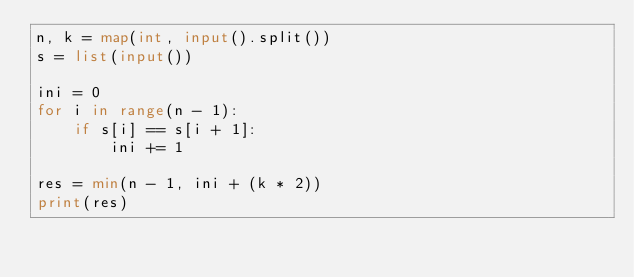Convert code to text. <code><loc_0><loc_0><loc_500><loc_500><_Python_>n, k = map(int, input().split())
s = list(input())

ini = 0
for i in range(n - 1):
	if s[i] == s[i + 1]:
		ini += 1

res = min(n - 1, ini + (k * 2))
print(res)</code> 